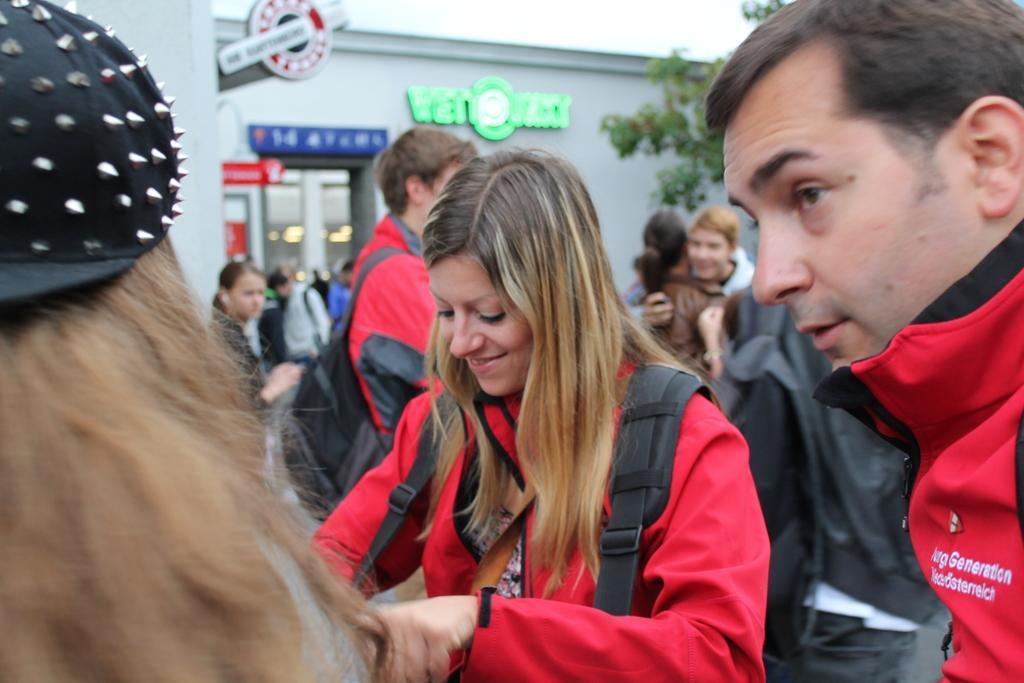Describe this image in one or two sentences. In this image there is a group of people behind them there is a building and tree. 